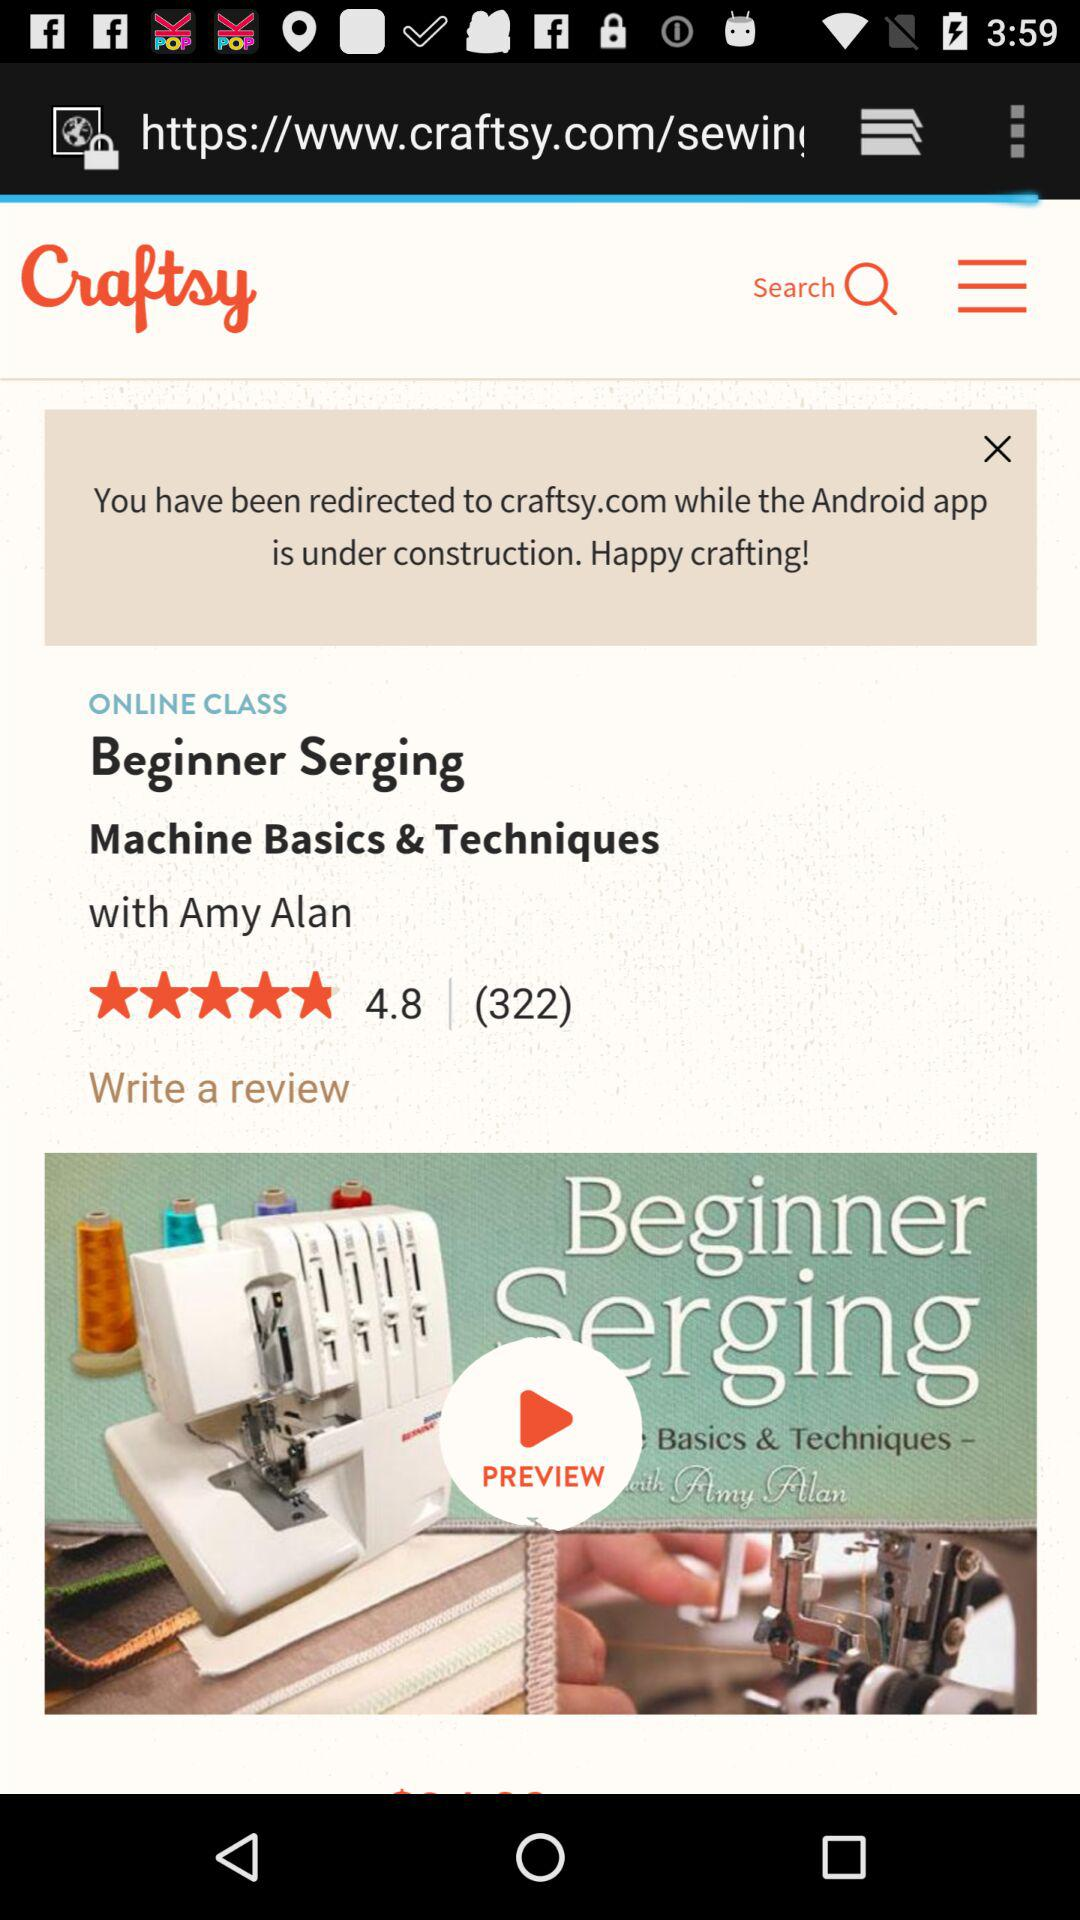How many reviews are given for "Beginner Serging Machine Basics & Techniques"? There are 322 reviews. 